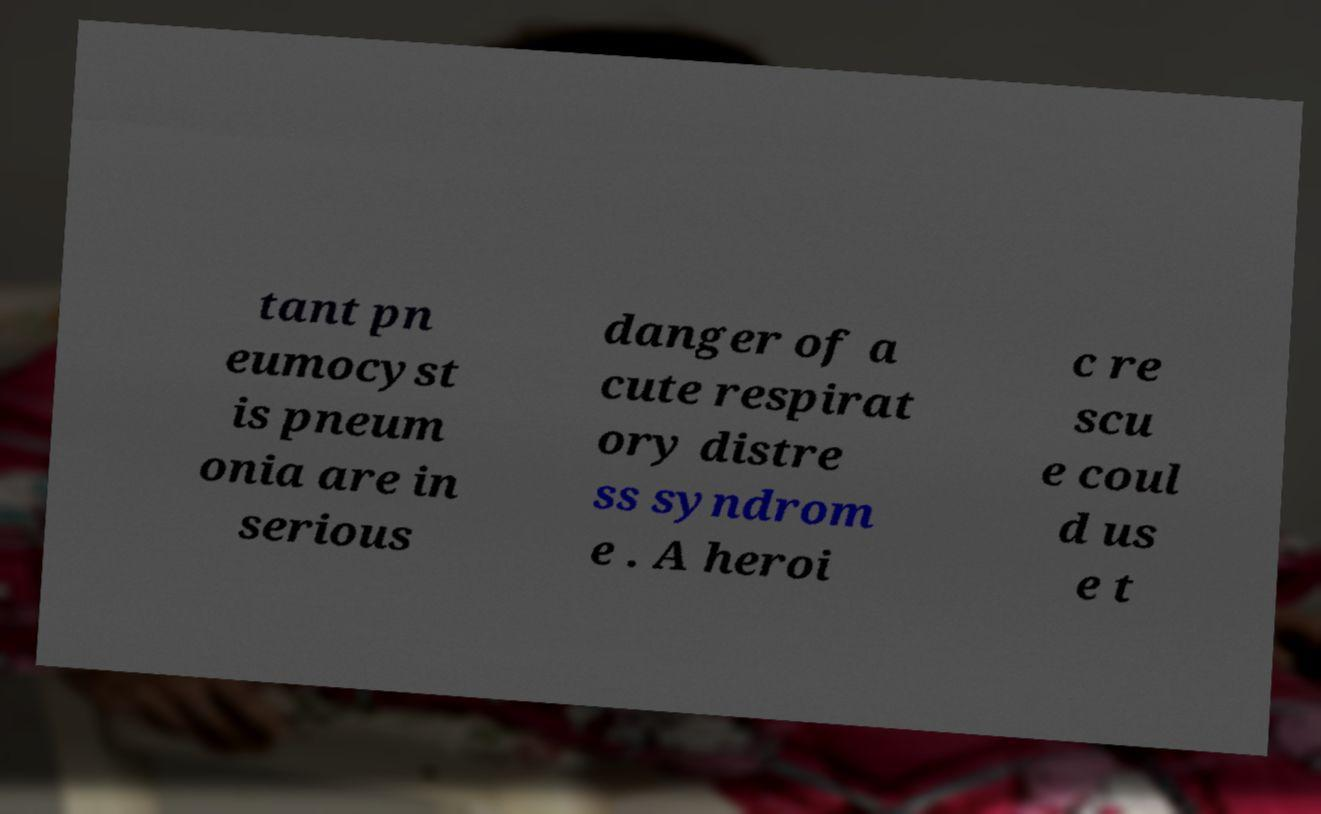Please read and relay the text visible in this image. What does it say? tant pn eumocyst is pneum onia are in serious danger of a cute respirat ory distre ss syndrom e . A heroi c re scu e coul d us e t 